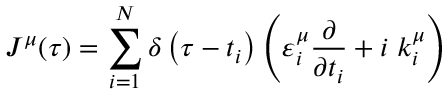<formula> <loc_0><loc_0><loc_500><loc_500>J ^ { \mu } ( \tau ) = \sum _ { i = 1 } ^ { N } \delta \left ( \tau - t _ { i } \right ) \left ( \varepsilon _ { i } ^ { \mu } \frac { \partial } \partial t _ { i } } + i \, k _ { i } ^ { \mu } \right )</formula> 